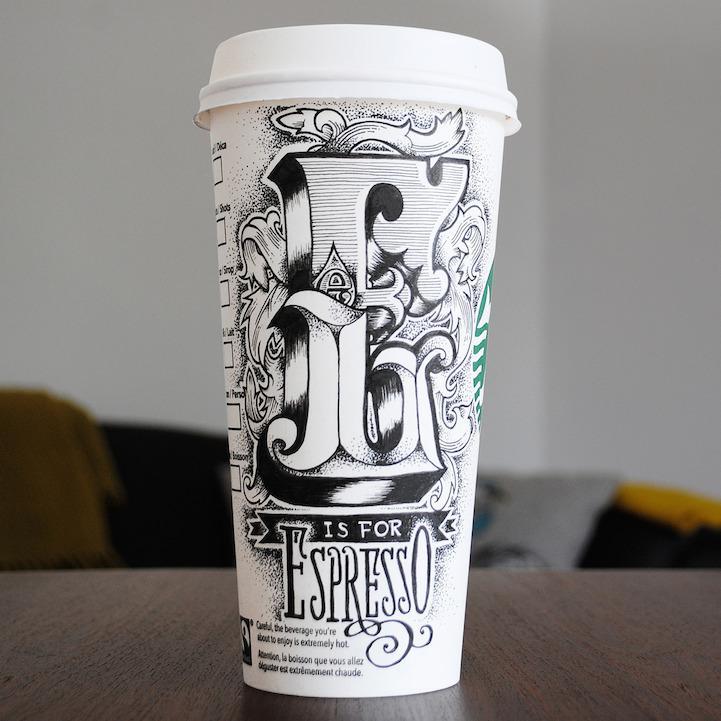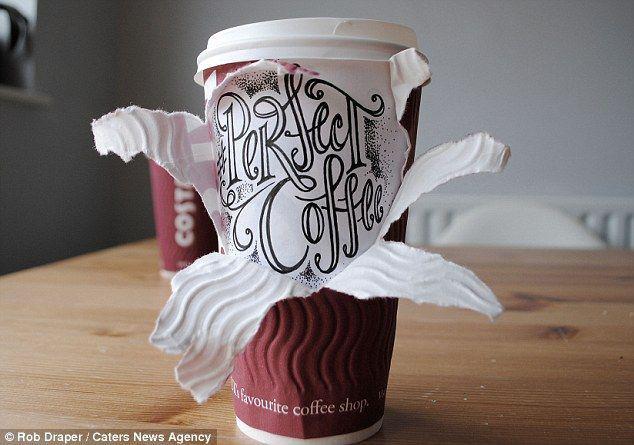The first image is the image on the left, the second image is the image on the right. For the images displayed, is the sentence "There are exactly five cups." factually correct? Answer yes or no. No. The first image is the image on the left, the second image is the image on the right. Given the left and right images, does the statement "There are five coffee cups." hold true? Answer yes or no. No. 